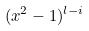<formula> <loc_0><loc_0><loc_500><loc_500>( x ^ { 2 } - 1 ) ^ { l - i }</formula> 